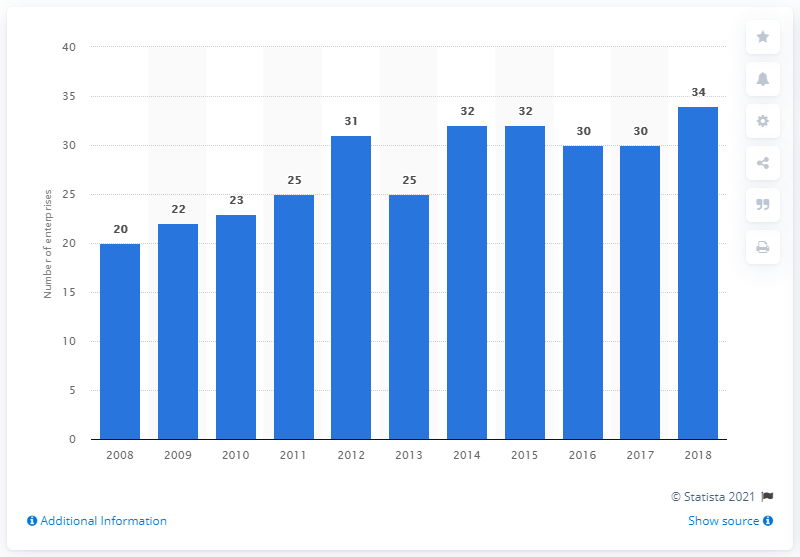List a handful of essential elements in this visual. In 2018, there were 34 enterprises in Latvia's manufacturing sector. 